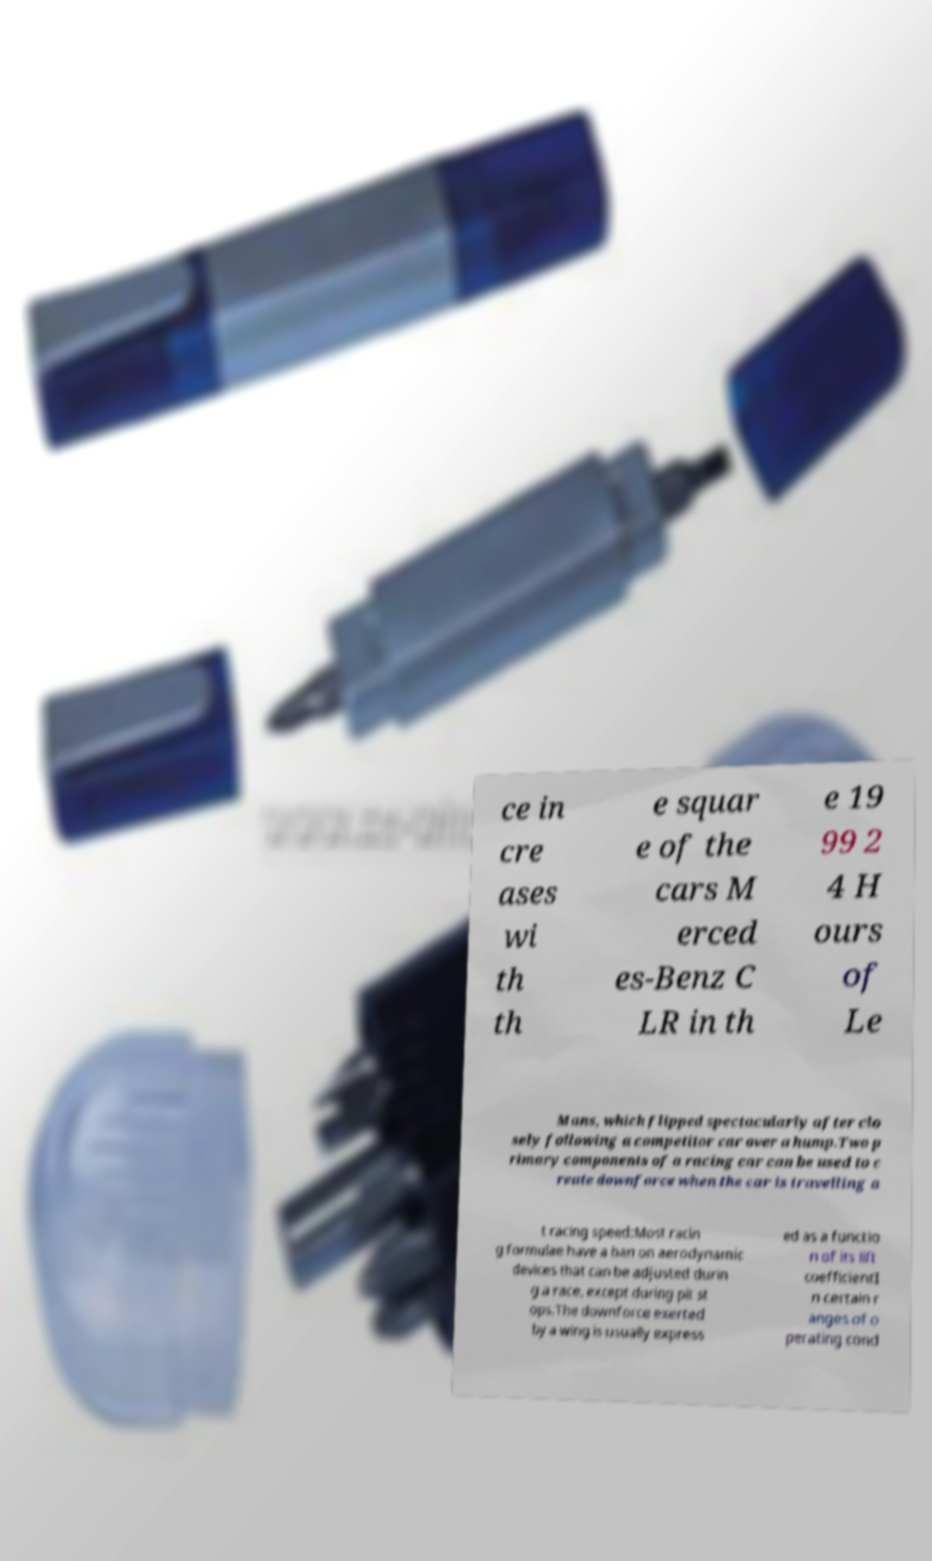Please read and relay the text visible in this image. What does it say? ce in cre ases wi th th e squar e of the cars M erced es-Benz C LR in th e 19 99 2 4 H ours of Le Mans, which flipped spectacularly after clo sely following a competitor car over a hump.Two p rimary components of a racing car can be used to c reate downforce when the car is travelling a t racing speed:Most racin g formulae have a ban on aerodynamic devices that can be adjusted durin g a race, except during pit st ops.The downforce exerted by a wing is usually express ed as a functio n of its lift coefficientI n certain r anges of o perating cond 